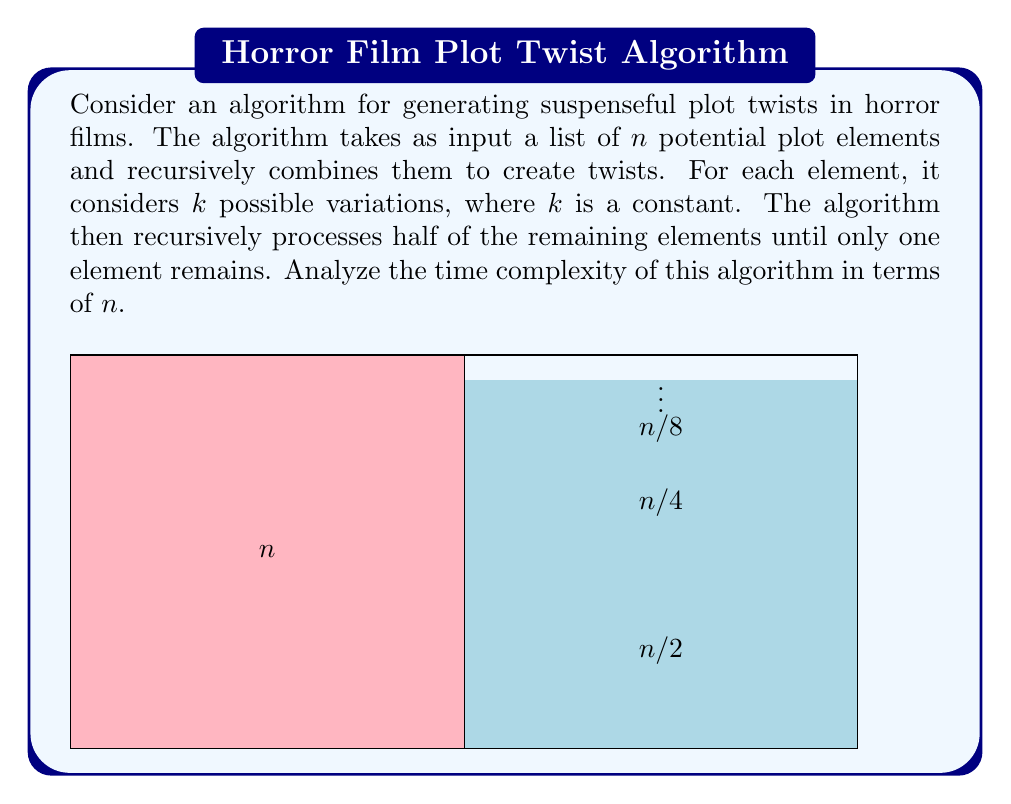Show me your answer to this math problem. Let's analyze this algorithm step-by-step:

1) At each level of recursion, the algorithm processes $n$ elements and considers $k$ variations for each. This takes $O(kn)$ time.

2) After processing, it recursively calls itself on half of the remaining elements. This creates a recurrence relation:

   $T(n) = kn + T(n/2)$

3) We can expand this recurrence:
   $T(n) = kn + k(n/2) + k(n/4) + ... + k(1)$

4) This forms a geometric series with $\log_2 n$ terms:
   $T(n) = kn(1 + 1/2 + 1/4 + ... + 1/n)$

5) The sum of this geometric series is bounded by 2:
   $1 + 1/2 + 1/4 + ... \leq 2$

6) Therefore, we can simplify:
   $T(n) \leq 2kn$

7) Since $k$ is a constant, we can drop it from our big O notation.

Thus, the time complexity of this algorithm is $O(n)$.
Answer: $O(n)$ 